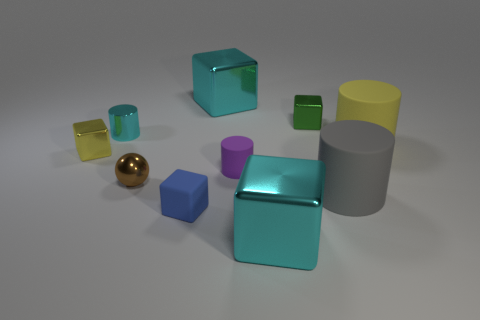Subtract all green cubes. How many cubes are left? 4 Subtract 2 blocks. How many blocks are left? 3 Subtract all blue matte blocks. How many blocks are left? 4 Subtract all purple blocks. Subtract all purple spheres. How many blocks are left? 5 Subtract all spheres. How many objects are left? 9 Add 6 small matte blocks. How many small matte blocks are left? 7 Add 4 brown cubes. How many brown cubes exist? 4 Subtract 0 purple balls. How many objects are left? 10 Subtract all large yellow metal cylinders. Subtract all tiny brown balls. How many objects are left? 9 